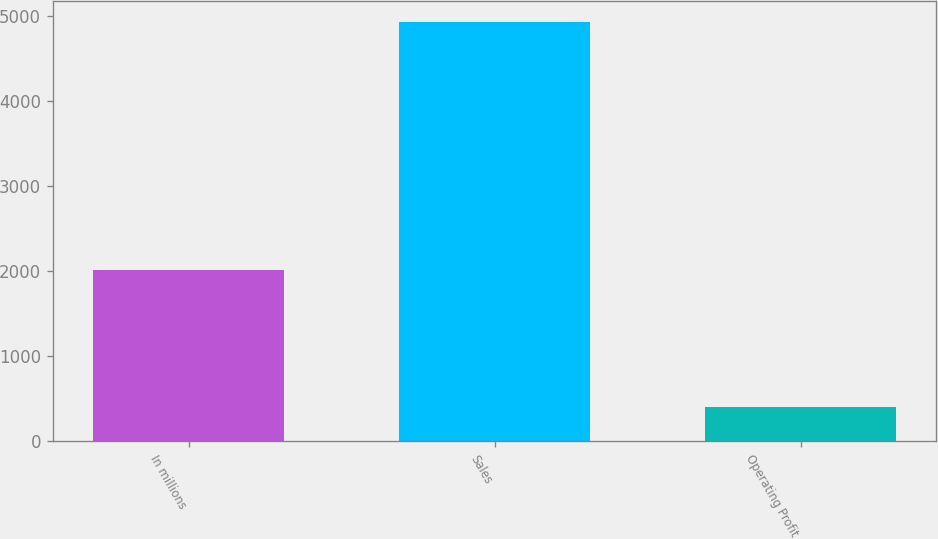<chart> <loc_0><loc_0><loc_500><loc_500><bar_chart><fcel>In millions<fcel>Sales<fcel>Operating Profit<nl><fcel>2006<fcel>4925<fcel>399<nl></chart> 